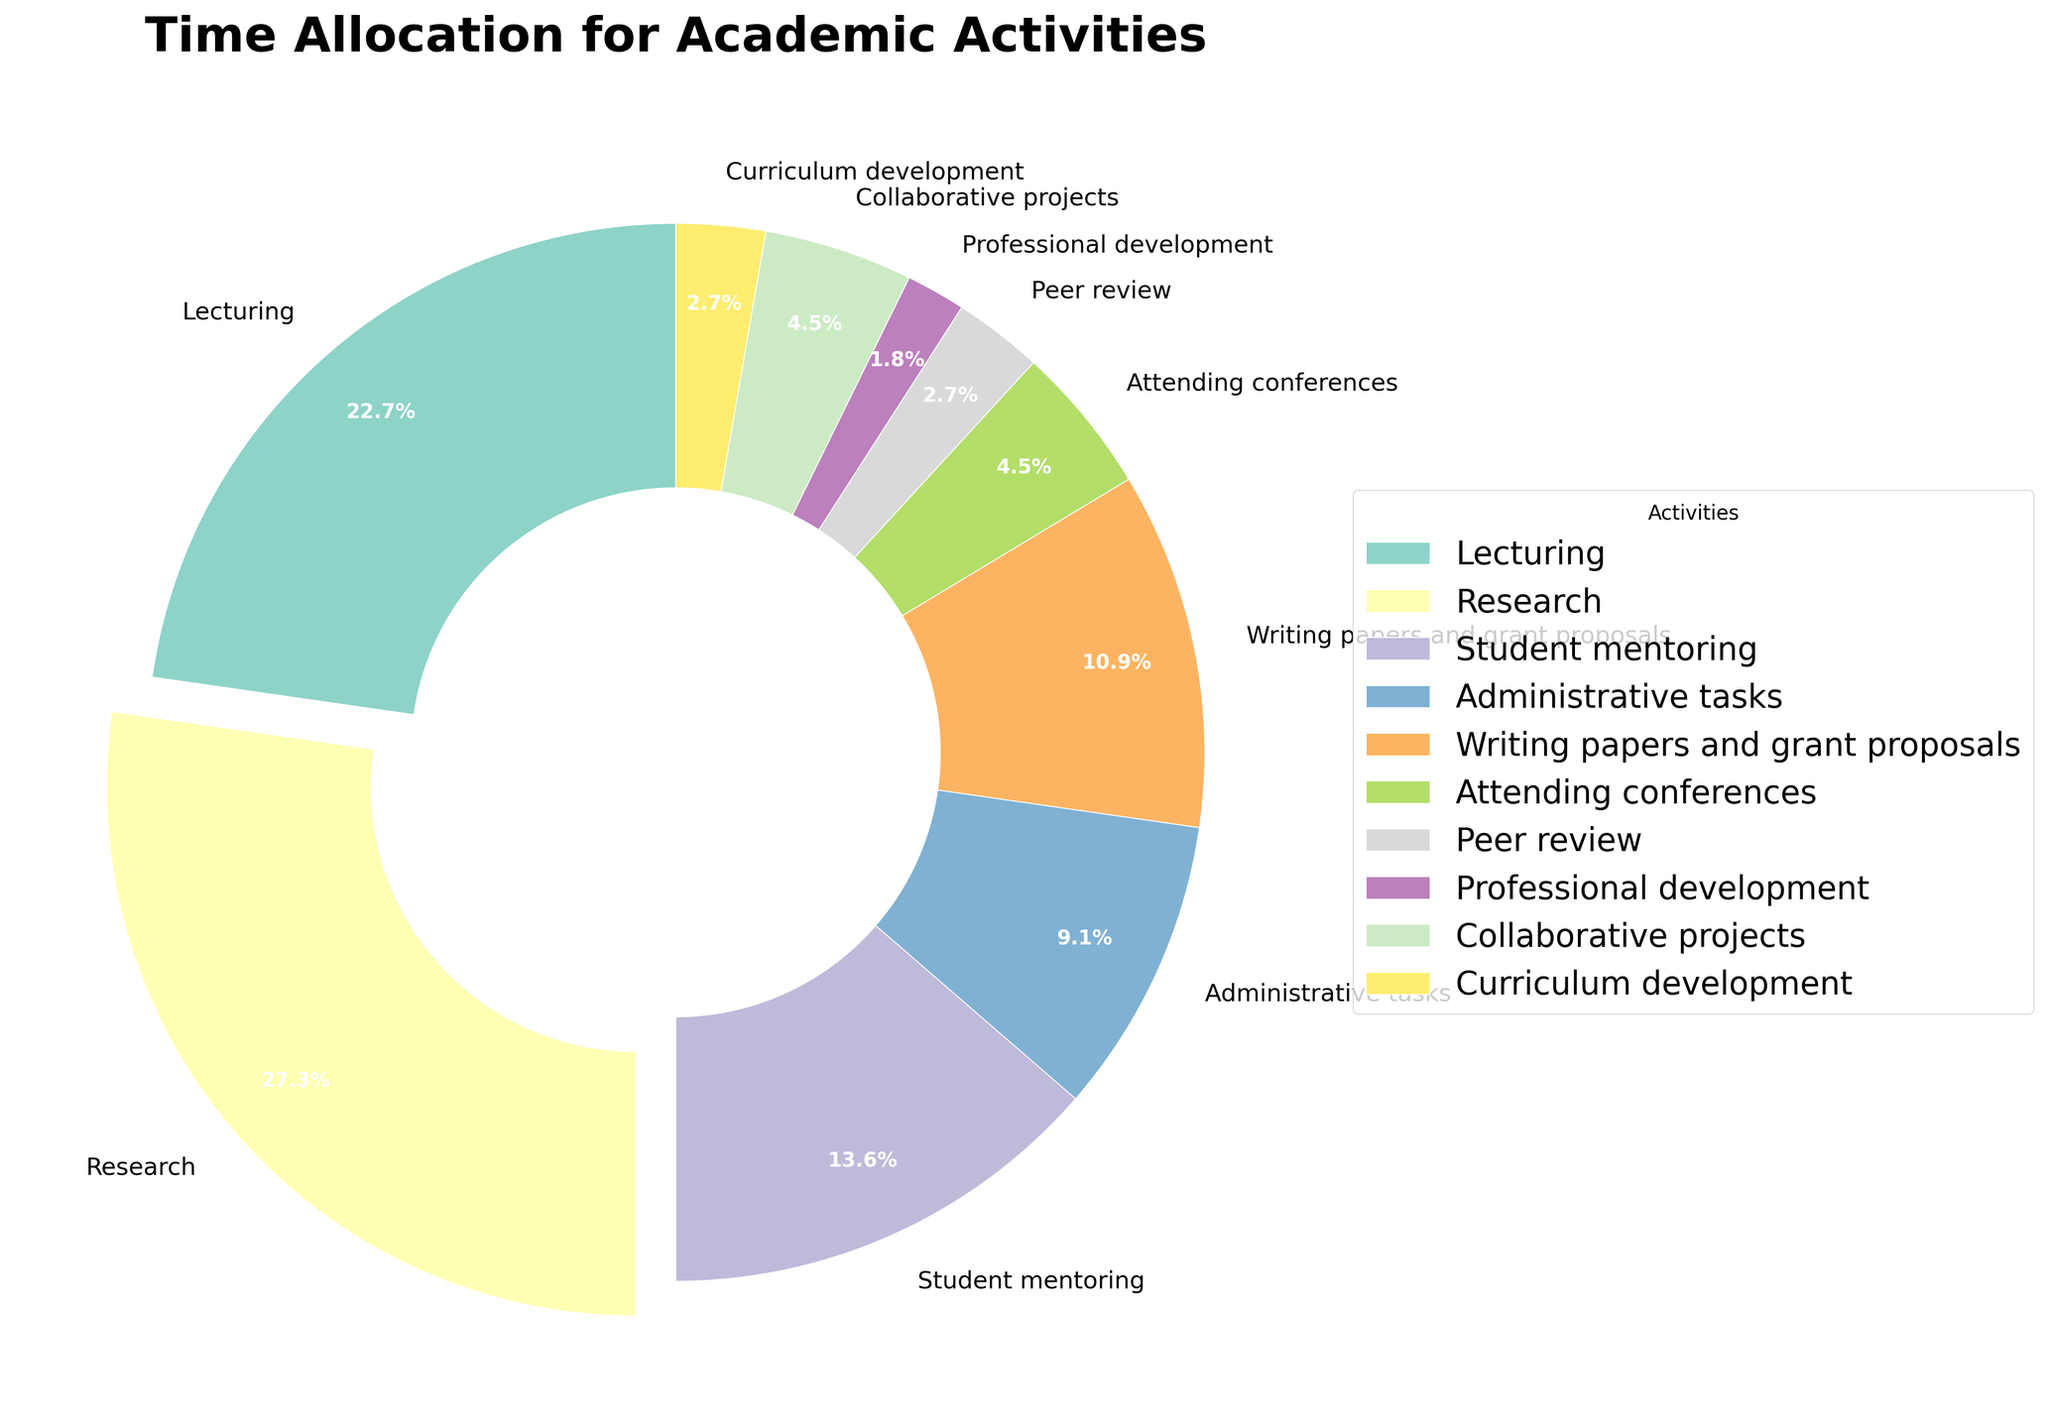What percentage of the time is spent on research and lecturing combined? To find the combined percentage of time spent on research and lecturing, sum the percentages allocated to each. Research is 30%, and lecturing is 25%. Therefore, the total is 30% + 25%.
Answer: 55% Which activity takes up more time, student mentoring or administrative tasks, and by how much? To find out which activity takes more time, compare the percentages for student mentoring and administrative tasks. Student mentoring is 15%, while administrative tasks are 10%. The difference is 15% - 10%.
Answer: Student mentoring, by 5% Which activity takes up the smallest percentage of time? To determine the activity with the smallest percentage of time, look for the category with the lowest percentage. The smallest percentage visible is 2% for professional development.
Answer: Professional development What is the percentage difference between time spent on writing papers and attending conferences? To find the percentage difference, subtract the percentage of time spent on attending conferences from the percentage spent on writing papers and grant proposals. Writing papers is 12%, attending conferences is 5%. The difference is 12% - 5%.
Answer: 7% What is the total percentage of time spent on activities that involve interacting with others (student mentoring, attending conferences, and collaborative projects)? Sum the percentages for student mentoring, attending conferences, and collaborative projects. These are 15%, 5%, and 5%, respectively. Adding them together gives 15% + 5% + 5%.
Answer: 25% Which activities have a lower time allocation than writing papers and grant proposals? Compare the percentages for all activities against the 12% allocated to writing papers and grant proposals. Activities with lower percentages are student mentoring (15%), administrative tasks (10%), attending conferences (5%), peer review (3%), professional development (2%), collaborative projects (5%), and curriculum development (3%).
Answer: Administrative tasks, attending conferences, peer review, professional development, collaborative projects, curriculum development What percentage of time is spent on non-teaching activities (excluding lecturing, student mentoring, and curriculum development)? Sum the percentages for all activities except lecturing, student mentoring, and curriculum development. These percentages are 25% (lecturing), 15% (student mentoring), and 3% (curriculum development). The total for non-teaching activities is 100% - (25% + 15% + 3%).
Answer: 57% Which activity is the most visually emphasized in the pie chart and why? Identify the activity with the largest 'explode' section. The activity with the largest percentage, research at 30%, will be visually emphasized with an exploded slice.
Answer: Research, as it is 30% and largest What is the average percentage of time spent on administrative tasks and peer review? To find the average, sum the percentages for administrative tasks and peer review, then divide by 2. Administrative tasks are 10%, and peer review is 3%. The sum is 10% + 3% = 13%, and the average is 13% / 2.
Answer: 6.5% What are two activities that collectively make up 8% of the time? Identify two activities whose percentages sum to 8%. Peer review is 3%, and curriculum development is 3%. Together, they add up to 3% + 3%, so look for another activity such as professional development at 2%. Adding these gives 3% + 3% + 2%.
Answer: Peer review and curriculum development 